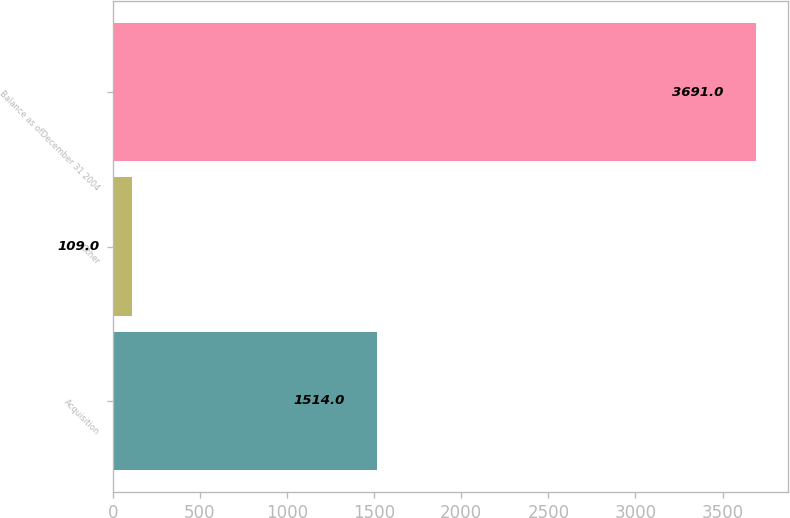Convert chart to OTSL. <chart><loc_0><loc_0><loc_500><loc_500><bar_chart><fcel>Acquisition<fcel>Other<fcel>Balance as ofDecember 31 2004<nl><fcel>1514<fcel>109<fcel>3691<nl></chart> 